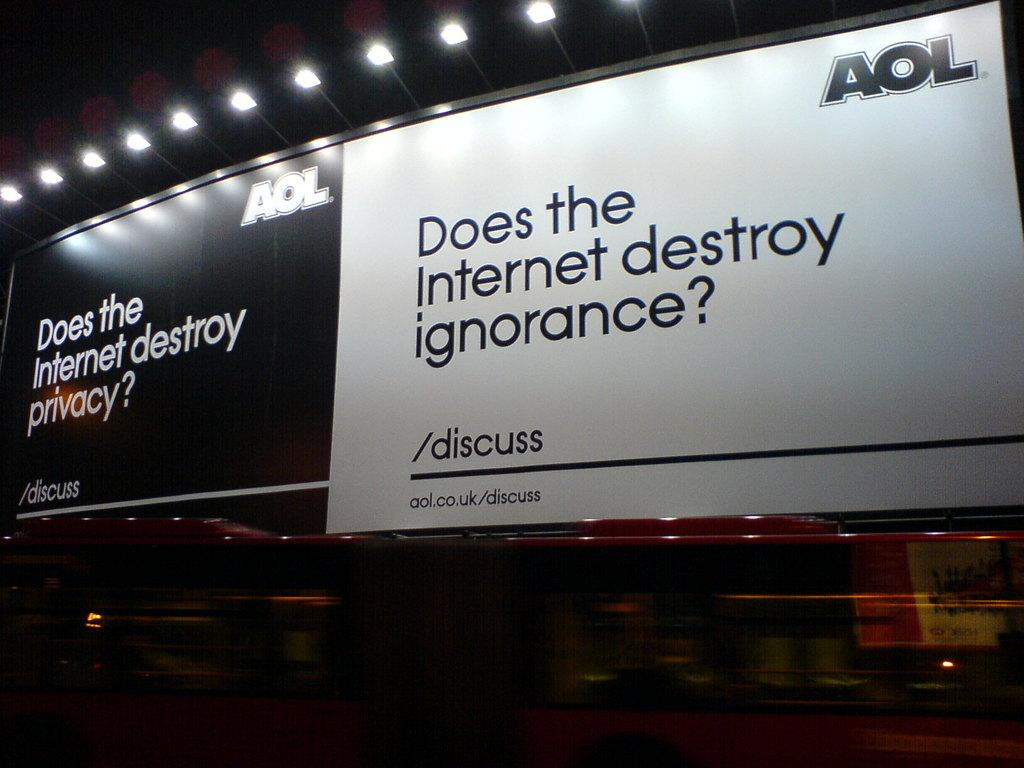<image>
Create a compact narrative representing the image presented. Two AOL signs that invites people to discuss how the interned destroys privacy and ignorance. 